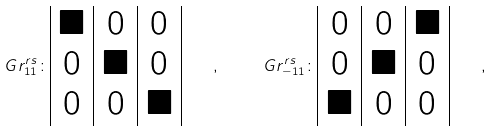<formula> <loc_0><loc_0><loc_500><loc_500>\ G r ^ { r s } _ { 1 1 } \colon \begin{array} { | c | c | c | } \blacksquare & 0 & 0 \\ 0 & \blacksquare & 0 \\ 0 & 0 & \blacksquare \\ \end{array} \quad , \quad \ G r ^ { r s } _ { - 1 1 } \colon \begin{array} { | c | c | c | } 0 & 0 & \blacksquare \\ 0 & \blacksquare & 0 \\ \blacksquare & 0 & 0 \\ \end{array} \quad ,</formula> 